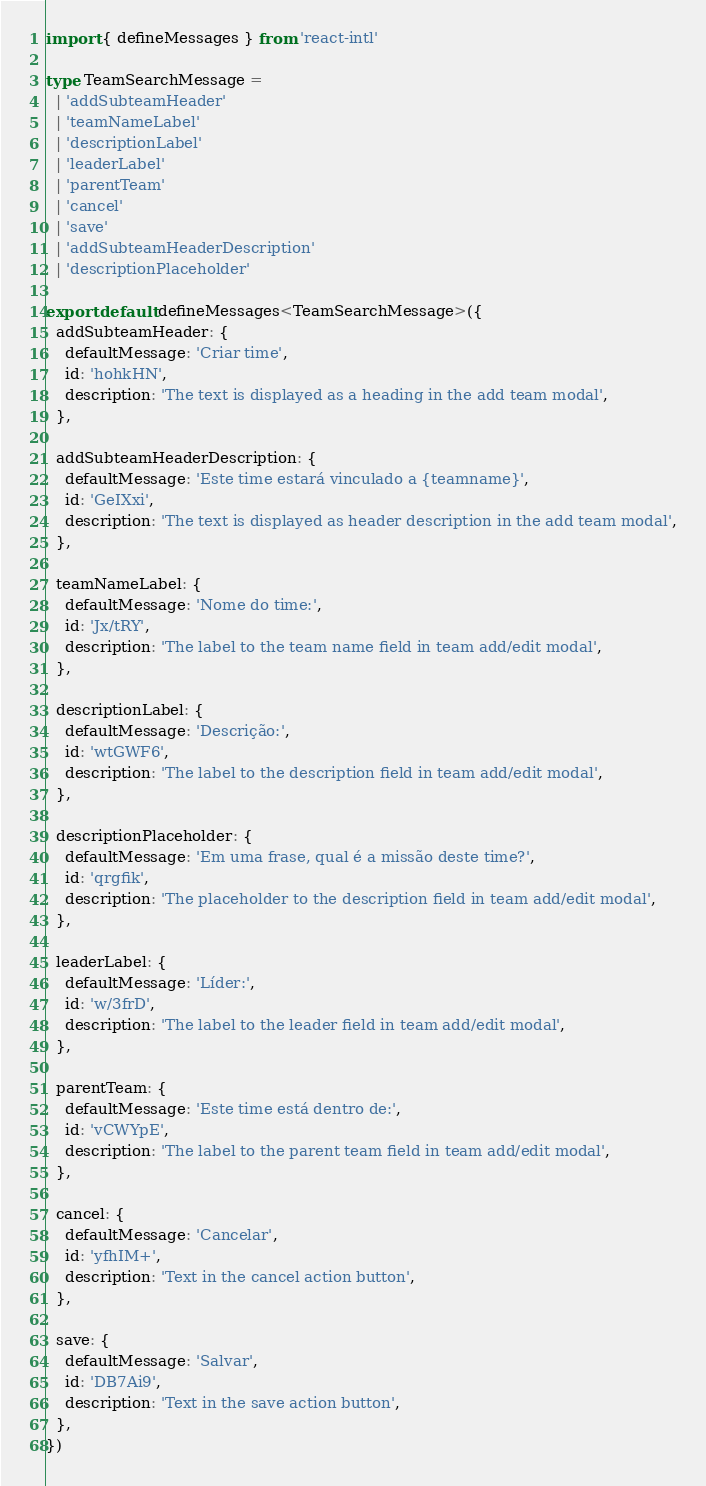<code> <loc_0><loc_0><loc_500><loc_500><_TypeScript_>import { defineMessages } from 'react-intl'

type TeamSearchMessage =
  | 'addSubteamHeader'
  | 'teamNameLabel'
  | 'descriptionLabel'
  | 'leaderLabel'
  | 'parentTeam'
  | 'cancel'
  | 'save'
  | 'addSubteamHeaderDescription'
  | 'descriptionPlaceholder'

export default defineMessages<TeamSearchMessage>({
  addSubteamHeader: {
    defaultMessage: 'Criar time',
    id: 'hohkHN',
    description: 'The text is displayed as a heading in the add team modal',
  },

  addSubteamHeaderDescription: {
    defaultMessage: 'Este time estará vinculado a {teamname}',
    id: 'GeIXxi',
    description: 'The text is displayed as header description in the add team modal',
  },

  teamNameLabel: {
    defaultMessage: 'Nome do time:',
    id: 'Jx/tRY',
    description: 'The label to the team name field in team add/edit modal',
  },

  descriptionLabel: {
    defaultMessage: 'Descrição:',
    id: 'wtGWF6',
    description: 'The label to the description field in team add/edit modal',
  },

  descriptionPlaceholder: {
    defaultMessage: 'Em uma frase, qual é a missão deste time?',
    id: 'qrgfik',
    description: 'The placeholder to the description field in team add/edit modal',
  },

  leaderLabel: {
    defaultMessage: 'Líder:',
    id: 'w/3frD',
    description: 'The label to the leader field in team add/edit modal',
  },

  parentTeam: {
    defaultMessage: 'Este time está dentro de:',
    id: 'vCWYpE',
    description: 'The label to the parent team field in team add/edit modal',
  },

  cancel: {
    defaultMessage: 'Cancelar',
    id: 'yfhIM+',
    description: 'Text in the cancel action button',
  },

  save: {
    defaultMessage: 'Salvar',
    id: 'DB7Ai9',
    description: 'Text in the save action button',
  },
})
</code> 